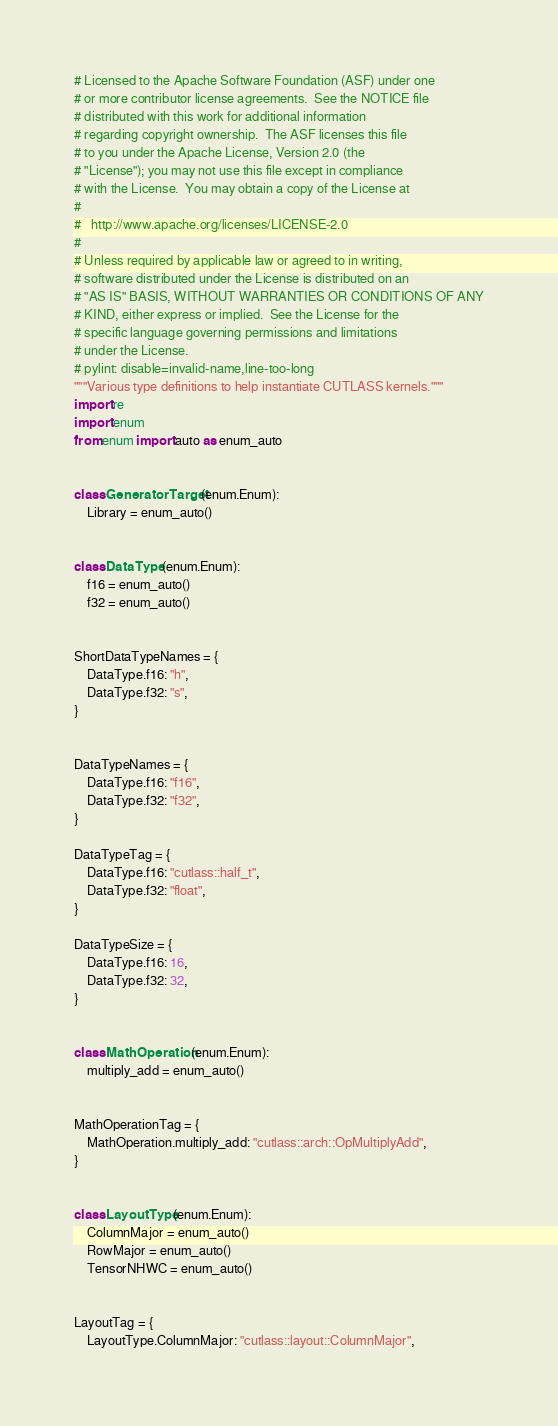Convert code to text. <code><loc_0><loc_0><loc_500><loc_500><_Python_># Licensed to the Apache Software Foundation (ASF) under one
# or more contributor license agreements.  See the NOTICE file
# distributed with this work for additional information
# regarding copyright ownership.  The ASF licenses this file
# to you under the Apache License, Version 2.0 (the
# "License"); you may not use this file except in compliance
# with the License.  You may obtain a copy of the License at
#
#   http://www.apache.org/licenses/LICENSE-2.0
#
# Unless required by applicable law or agreed to in writing,
# software distributed under the License is distributed on an
# "AS IS" BASIS, WITHOUT WARRANTIES OR CONDITIONS OF ANY
# KIND, either express or implied.  See the License for the
# specific language governing permissions and limitations
# under the License.
# pylint: disable=invalid-name,line-too-long
"""Various type definitions to help instantiate CUTLASS kernels."""
import re
import enum
from enum import auto as enum_auto


class GeneratorTarget(enum.Enum):
    Library = enum_auto()


class DataType(enum.Enum):
    f16 = enum_auto()
    f32 = enum_auto()


ShortDataTypeNames = {
    DataType.f16: "h",
    DataType.f32: "s",
}


DataTypeNames = {
    DataType.f16: "f16",
    DataType.f32: "f32",
}

DataTypeTag = {
    DataType.f16: "cutlass::half_t",
    DataType.f32: "float",
}

DataTypeSize = {
    DataType.f16: 16,
    DataType.f32: 32,
}


class MathOperation(enum.Enum):
    multiply_add = enum_auto()


MathOperationTag = {
    MathOperation.multiply_add: "cutlass::arch::OpMultiplyAdd",
}


class LayoutType(enum.Enum):
    ColumnMajor = enum_auto()
    RowMajor = enum_auto()
    TensorNHWC = enum_auto()


LayoutTag = {
    LayoutType.ColumnMajor: "cutlass::layout::ColumnMajor",</code> 